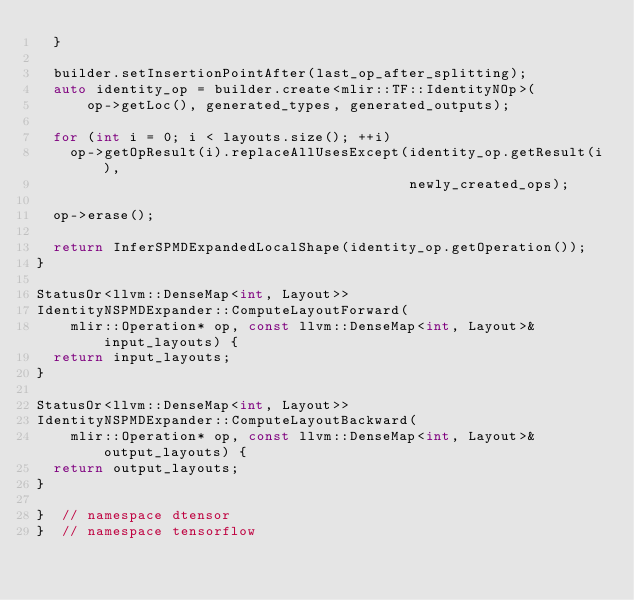<code> <loc_0><loc_0><loc_500><loc_500><_C++_>  }

  builder.setInsertionPointAfter(last_op_after_splitting);
  auto identity_op = builder.create<mlir::TF::IdentityNOp>(
      op->getLoc(), generated_types, generated_outputs);

  for (int i = 0; i < layouts.size(); ++i)
    op->getOpResult(i).replaceAllUsesExcept(identity_op.getResult(i),
                                            newly_created_ops);

  op->erase();

  return InferSPMDExpandedLocalShape(identity_op.getOperation());
}

StatusOr<llvm::DenseMap<int, Layout>>
IdentityNSPMDExpander::ComputeLayoutForward(
    mlir::Operation* op, const llvm::DenseMap<int, Layout>& input_layouts) {
  return input_layouts;
}

StatusOr<llvm::DenseMap<int, Layout>>
IdentityNSPMDExpander::ComputeLayoutBackward(
    mlir::Operation* op, const llvm::DenseMap<int, Layout>& output_layouts) {
  return output_layouts;
}

}  // namespace dtensor
}  // namespace tensorflow
</code> 